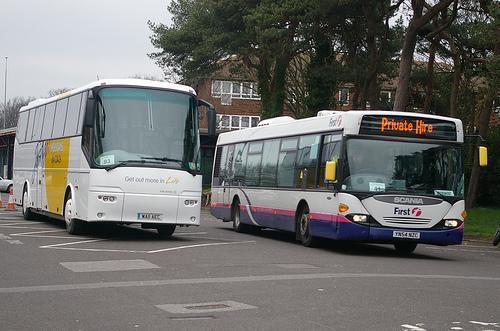How many buses are visible?
Give a very brief answer. 2. 